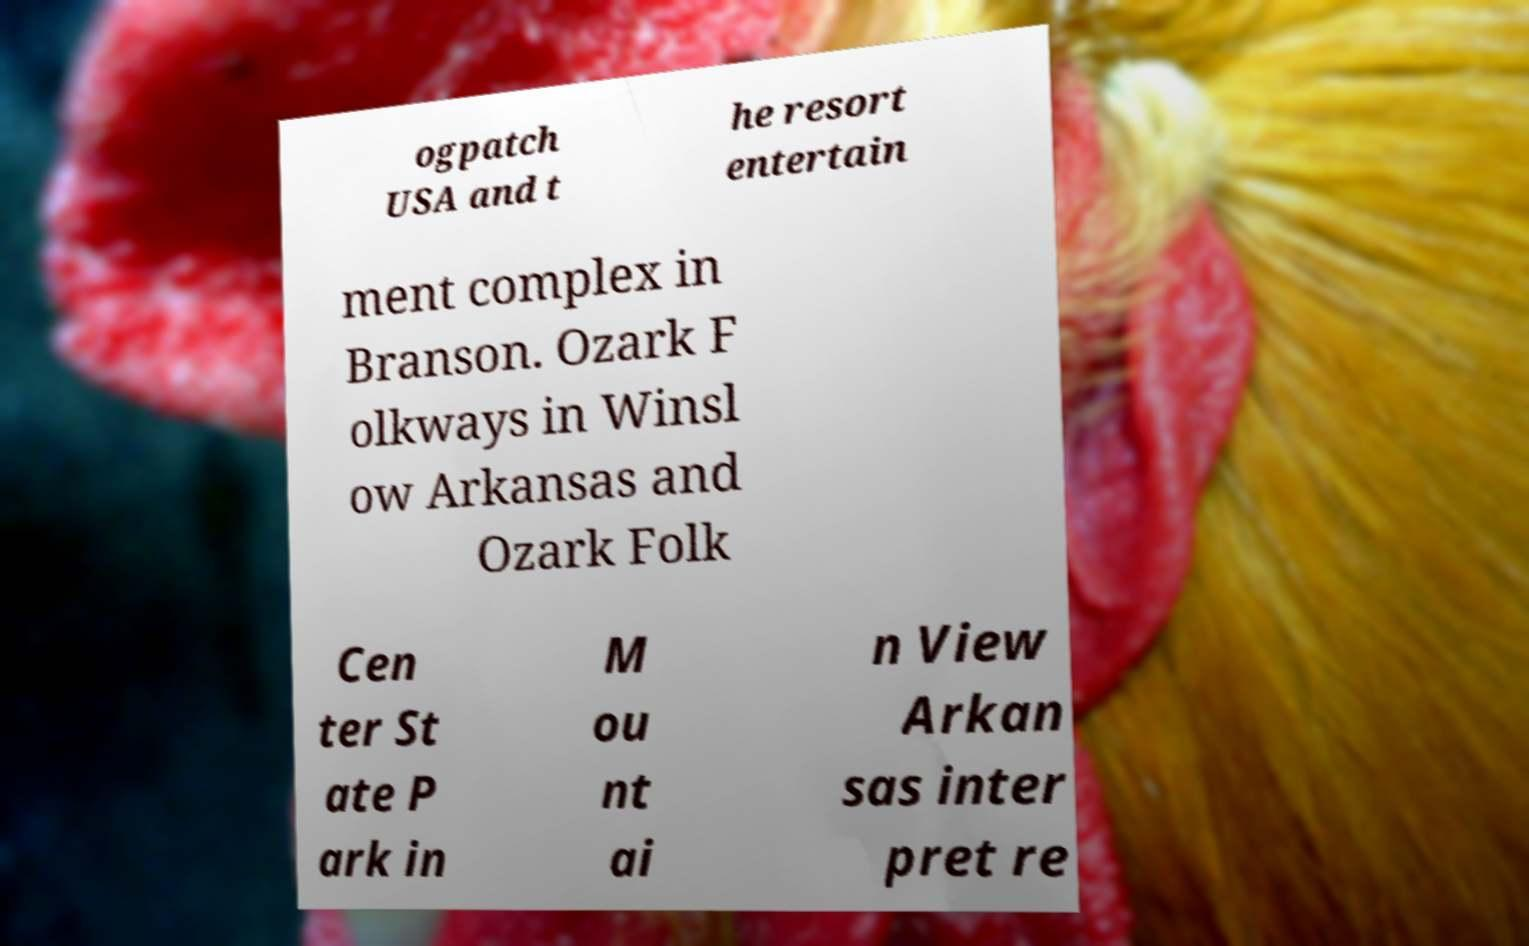Can you read and provide the text displayed in the image?This photo seems to have some interesting text. Can you extract and type it out for me? ogpatch USA and t he resort entertain ment complex in Branson. Ozark F olkways in Winsl ow Arkansas and Ozark Folk Cen ter St ate P ark in M ou nt ai n View Arkan sas inter pret re 